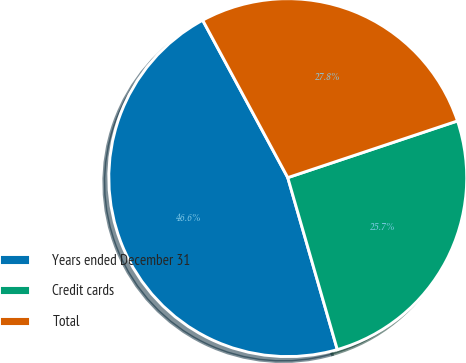Convert chart to OTSL. <chart><loc_0><loc_0><loc_500><loc_500><pie_chart><fcel>Years ended December 31<fcel>Credit cards<fcel>Total<nl><fcel>46.58%<fcel>25.67%<fcel>27.76%<nl></chart> 